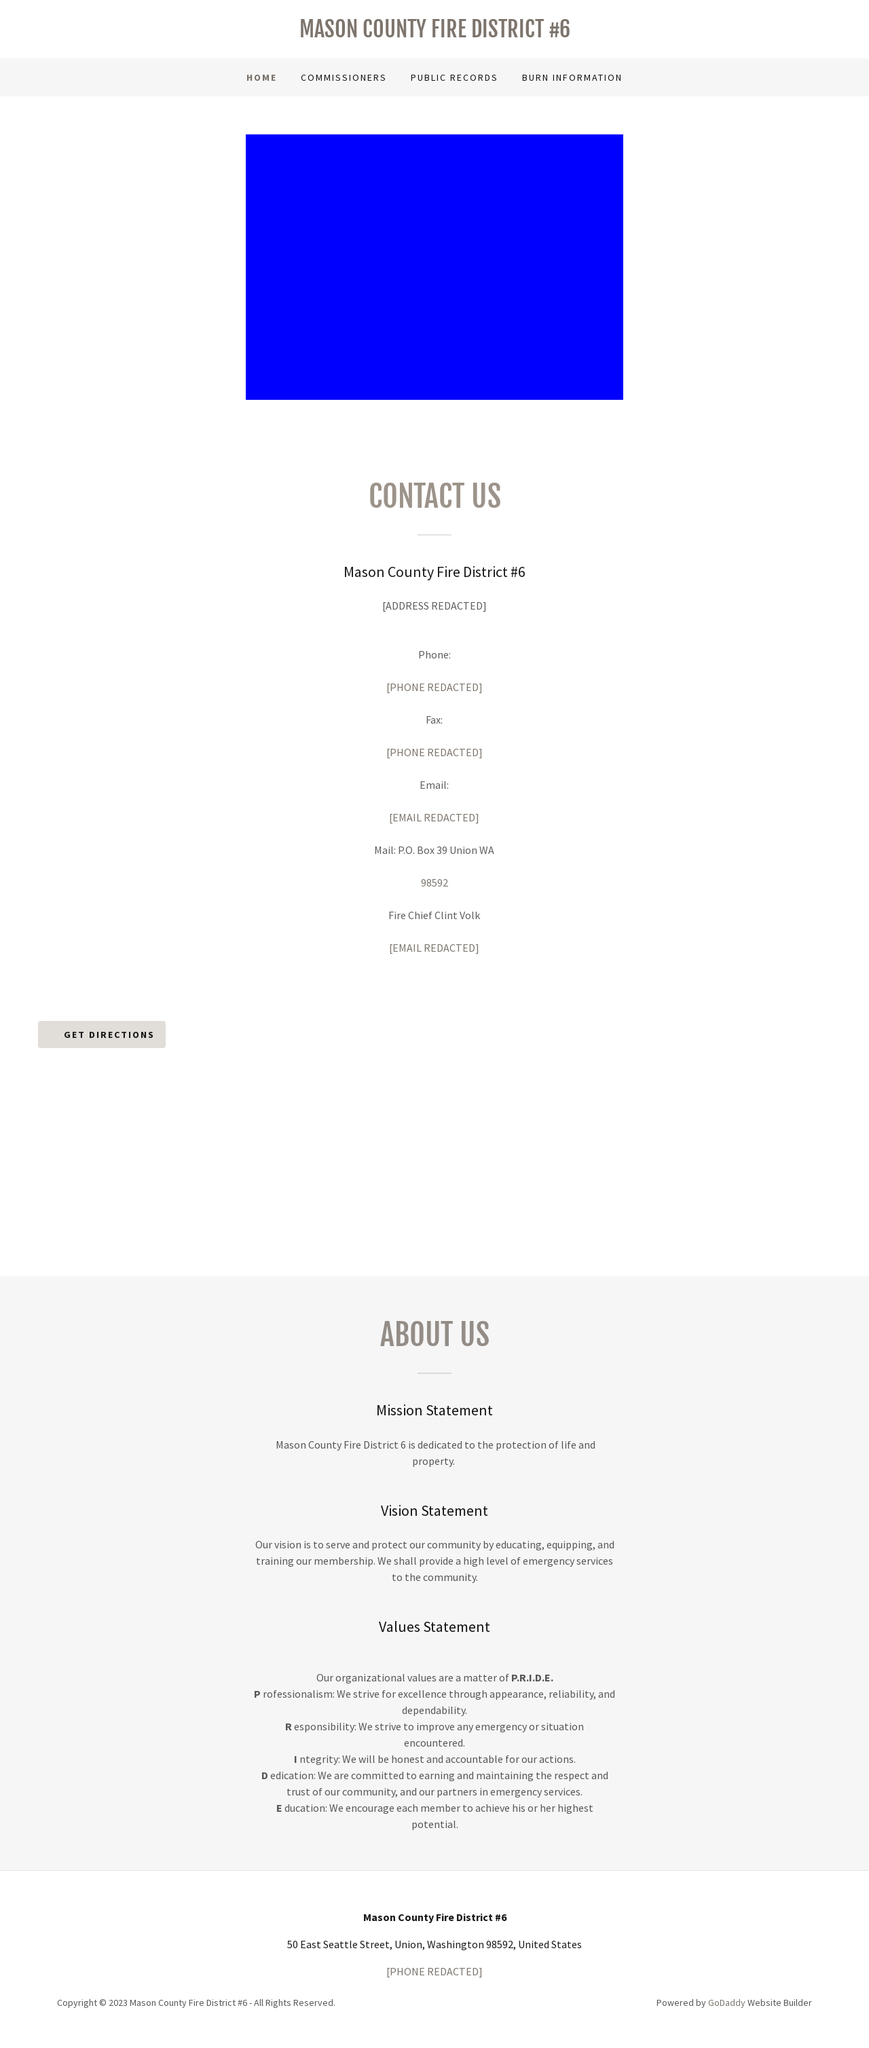How is the 'Values Statement' related to the overall mission of the fire district? The 'Values Statement' is deeply connected to the fire district's mission. By emphasizing qualities like professionalism, responsibility, integrity, dedication, and education, the district ensures it adheres to high standards. These values support their mission to protect life and property by maintaining trust and operational efficiency within the community. These values influence daily operations by setting a framework for decision-making and behavior. For instance, professionalism ensures that all personnel maintain a reliable and commendable appearance and conduct. Dedication and integrity mean staff are committed and honest in emergency responses, forging stronger trust. Education ensures ongoing training, which is crucial for handling diverse emergencies effectively. 